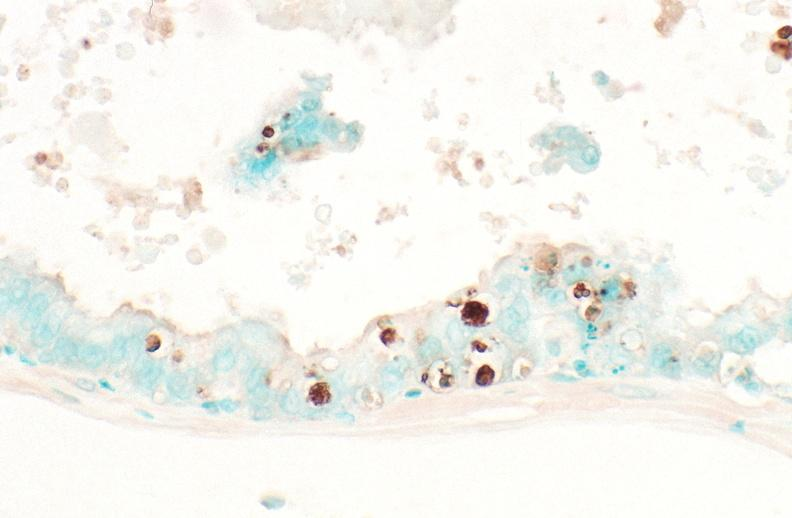do apoptosis tunel stain?
Answer the question using a single word or phrase. Yes 